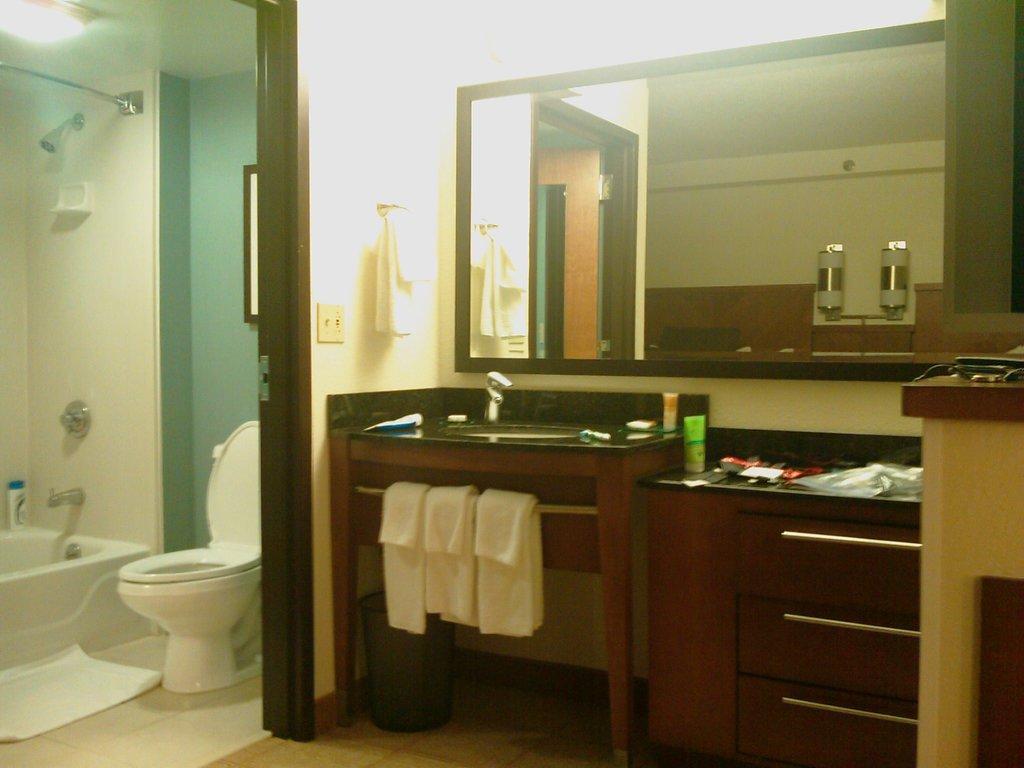In one or two sentences, can you explain what this image depicts? In this picture I can see the inside view of a room and I can see a wash basin in the center of this image and under that I see 3 white color clothes and I see a bin. On the top of this picture I can see the lights and under the lights I can see the mirror. On the left side of this image I can see a bathtub, a tap and a toilet seat. On the top left corner of this image I can see another light and I can see few things on the right side of this picture. 